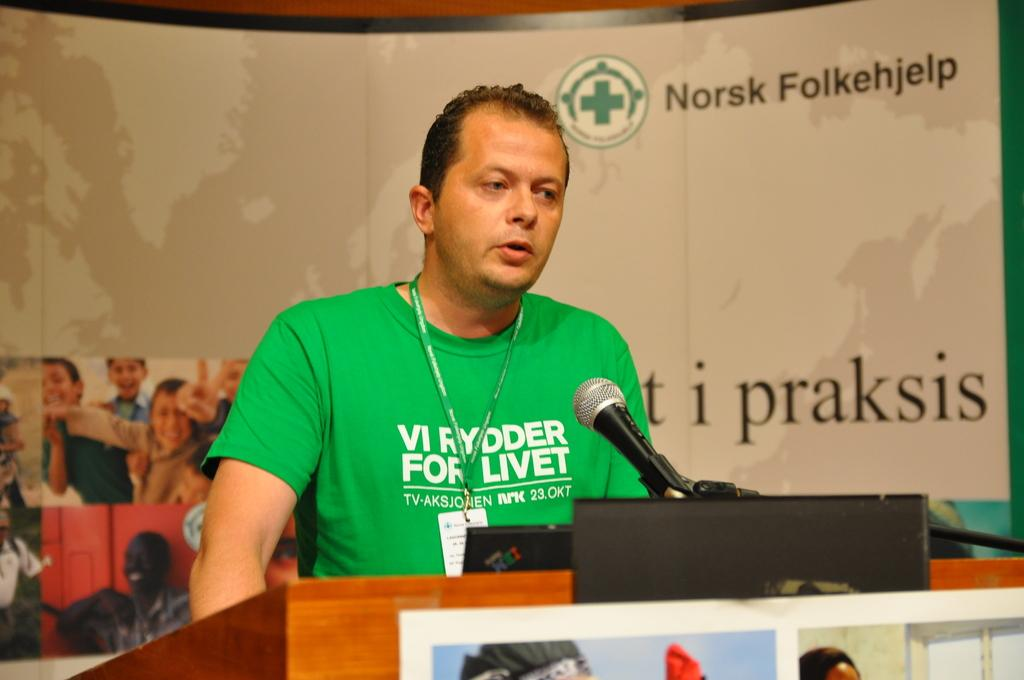Who is the main subject in the image? There is a man in the middle of the image. What object is in front of the man? There is a microphone in front of the man. What structure is in front of the man, supporting the microphone? There is a podium in front of the man. What can be seen in the background of the image? There is a hoarding in the background of the image. What type of lumber is being used to construct the podium in the image? There is no information about the type of lumber used to construct the podium in the image. Can you see a pencil on the podium in the image? There is no mention of a pencil in the image. 